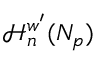Convert formula to latex. <formula><loc_0><loc_0><loc_500><loc_500>\mathcal { H } _ { n } ^ { w ^ { \prime } } ( N _ { p } )</formula> 